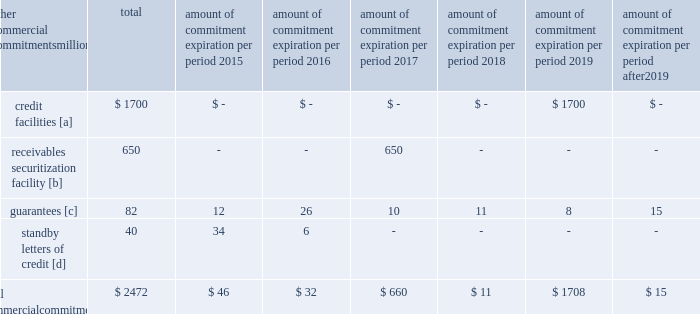Amount of commitment expiration per period other commercial commitments after millions total 2015 2016 2017 2018 2019 2019 .
[a] none of the credit facility was used as of december 31 , 2014 .
[b] $ 400 million of the receivables securitization facility was utilized as of december 31 , 2014 , which is accounted for as debt .
The full program matures in july 2017 .
[c] includes guaranteed obligations related to our equipment financings and affiliated operations .
[d] none of the letters of credit were drawn upon as of december 31 , 2014 .
Off-balance sheet arrangements guarantees 2013 at december 31 , 2014 , and 2013 , we were contingently liable for $ 82 million and $ 299 million in guarantees .
We have recorded liabilities of $ 0.3 million and $ 1 million for the fair value of these obligations as of december 31 , 2014 , and 2013 , respectively .
We entered into these contingent guarantees in the normal course of business , and they include guaranteed obligations related to our equipment financings and affiliated operations .
The final guarantee expires in 2022 .
We are not aware of any existing event of default that would require us to satisfy these guarantees .
We do not expect that these guarantees will have a material adverse effect on our consolidated financial condition , results of operations , or liquidity .
Other matters labor agreements 2013 approximately 85% ( 85 % ) of our 47201 full-time-equivalent employees are represented by 14 major rail unions .
On january 1 , 2015 , current labor agreements became subject to modification and we began the current round of negotiations with the unions .
Existing agreements remain in effect until new agreements are reached or the railway labor act 2019s procedures ( which include mediation , cooling-off periods , and the possibility of presidential emergency boards and congressional intervention ) are exhausted .
Contract negotiations historically continue for an extended period of time and we rarely experience work stoppages while negotiations are pending .
Inflation 2013 long periods of inflation significantly increase asset replacement costs for capital-intensive companies .
As a result , assuming that we replace all operating assets at current price levels , depreciation charges ( on an inflation-adjusted basis ) would be substantially greater than historically reported amounts .
Derivative financial instruments 2013 we may use derivative financial instruments in limited instances to assist in managing our overall exposure to fluctuations in interest rates and fuel prices .
We are not a party to leveraged derivatives and , by policy , do not use derivative financial instruments for speculative purposes .
Derivative financial instruments qualifying for hedge accounting must maintain a specified level of effectiveness between the hedging instrument and the item being hedged , both at inception and throughout the hedged period .
We formally document the nature and relationships between the hedging instruments and hedged items at inception , as well as our risk-management objectives , strategies for undertaking the various hedge transactions , and method of assessing hedge effectiveness .
Changes in the fair market value of derivative financial instruments that do not qualify for hedge accounting are charged to earnings .
We may use swaps , collars , futures , and/or forward contracts to mitigate the risk of adverse movements in interest rates and fuel prices ; however , the use of these derivative financial instruments may limit future benefits from favorable price movements .
Market and credit risk 2013 we address market risk related to derivative financial instruments by selecting instruments with value fluctuations that highly correlate with the underlying hedged item .
We manage credit risk related to derivative financial instruments , which is minimal , by requiring high credit standards for counterparties and periodic settlements .
At december 31 , 2014 and 2013 , we were not required to provide collateral , nor had we received collateral , relating to our hedging activities. .
What percentage of the total commercial commitments is receivables securitization facility? 
Computations: (650 / 2472)
Answer: 0.26294. 